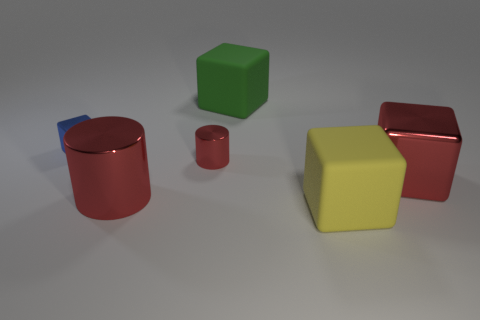How many things are large cyan cubes or big green rubber blocks?
Keep it short and to the point. 1. What material is the large red thing to the left of the rubber cube in front of the small blue metal object?
Keep it short and to the point. Metal. Is there a cube that has the same material as the small cylinder?
Keep it short and to the point. Yes. There is a tiny metal thing right of the metal block that is behind the thing on the right side of the big yellow matte object; what is its shape?
Your answer should be compact. Cylinder. What is the material of the green block?
Keep it short and to the point. Rubber. There is another object that is the same material as the big yellow thing; what is its color?
Offer a terse response. Green. There is a small metal thing in front of the tiny blue metallic object; are there any tiny red metal objects that are behind it?
Provide a succinct answer. No. How many other things are there of the same shape as the big green matte object?
Give a very brief answer. 3. Does the big object behind the tiny cylinder have the same shape as the small thing that is on the left side of the big shiny cylinder?
Provide a short and direct response. Yes. There is a big rubber cube behind the big matte thing that is in front of the small blue block; what number of rubber cubes are to the left of it?
Your answer should be very brief. 0. 